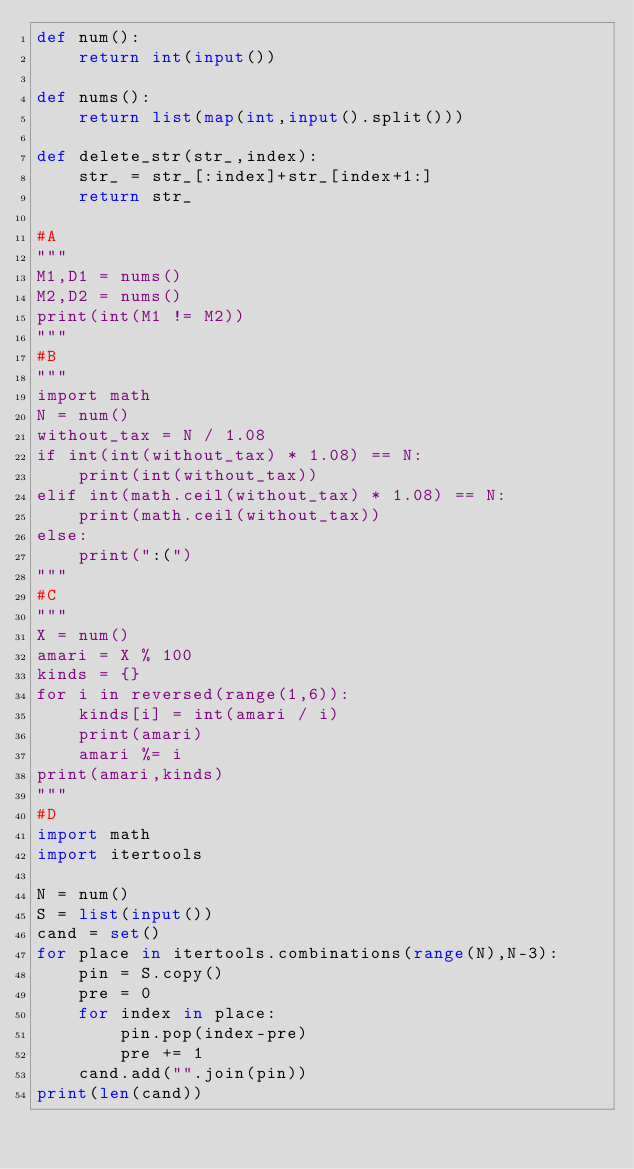Convert code to text. <code><loc_0><loc_0><loc_500><loc_500><_Python_>def num():
    return int(input())

def nums():
    return list(map(int,input().split()))

def delete_str(str_,index):
    str_ = str_[:index]+str_[index+1:]
    return str_

#A
"""
M1,D1 = nums()
M2,D2 = nums()
print(int(M1 != M2))
"""
#B
"""
import math
N = num()
without_tax = N / 1.08
if int(int(without_tax) * 1.08) == N:
    print(int(without_tax))
elif int(math.ceil(without_tax) * 1.08) == N:
    print(math.ceil(without_tax))
else:
    print(":(")
"""
#C
"""
X = num()
amari = X % 100
kinds = {}
for i in reversed(range(1,6)):
    kinds[i] = int(amari / i)
    print(amari)
    amari %= i
print(amari,kinds)
"""
#D
import math
import itertools

N = num()
S = list(input())
cand = set()
for place in itertools.combinations(range(N),N-3):
    pin = S.copy()
    pre = 0
    for index in place:
        pin.pop(index-pre)
        pre += 1
    cand.add("".join(pin))
print(len(cand))</code> 